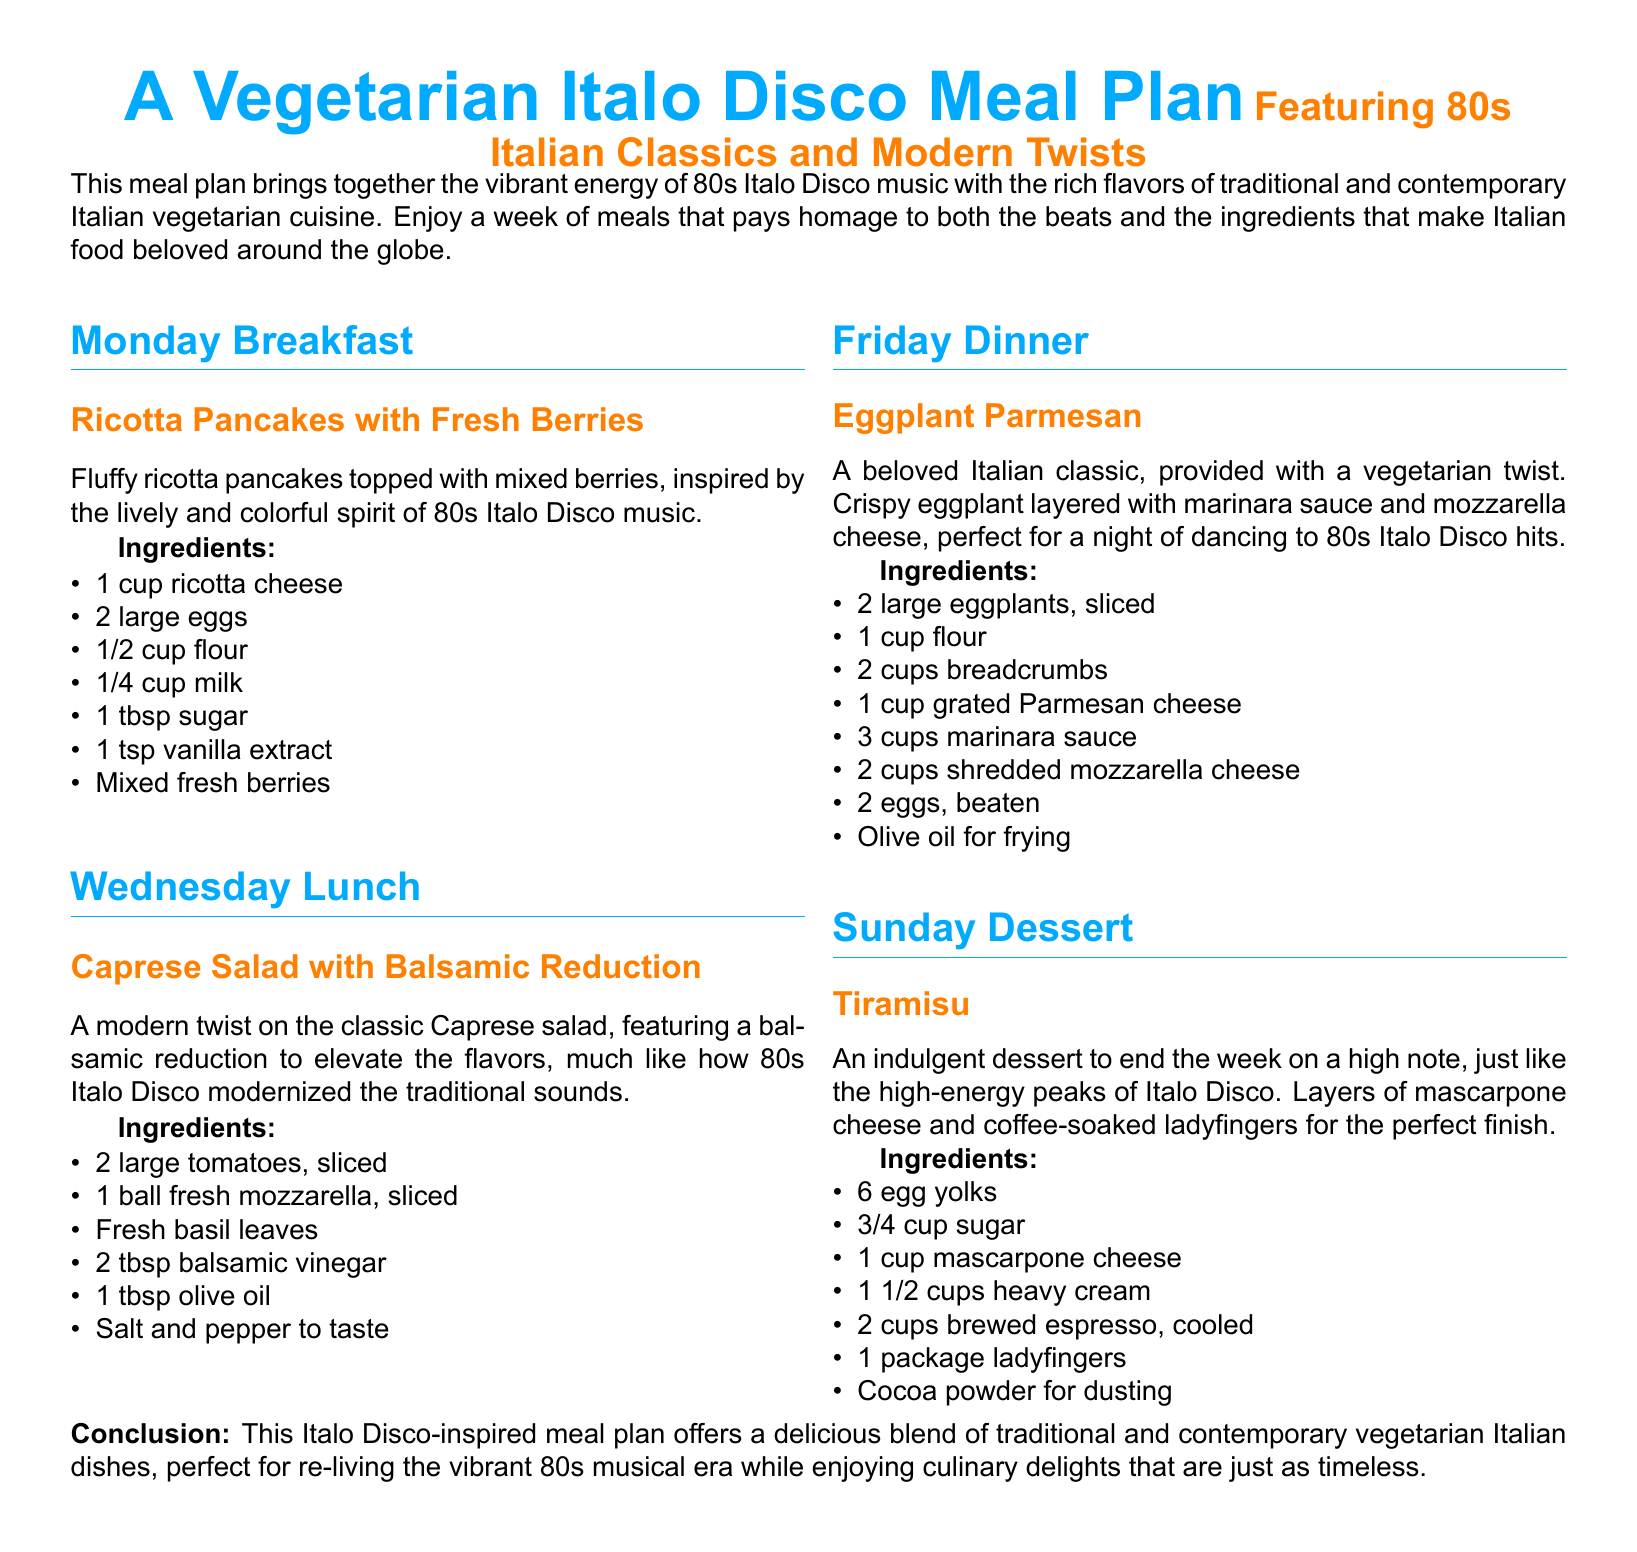What is the title of the meal plan? The title prominently displayed at the top is "A Vegetarian Italo Disco Meal Plan."
Answer: A Vegetarian Italo Disco Meal Plan What dish is served for Monday breakfast? The document specifies that Monday breakfast features "Ricotta Pancakes with Fresh Berries."
Answer: Ricotta Pancakes with Fresh Berries What is a key ingredient in the Caprese Salad? The Caprese Salad includes fresh mozzarella as one of its main ingredients.
Answer: Fresh mozzarella How many eggs are required for the Eggplant Parmesan? The recipe for Eggplant Parmesan calls for 2 eggs, as noted in the ingredient list.
Answer: 2 eggs Which dessert is featured on Sunday? The dessert listed for Sunday in the meal plan is "Tiramisu."
Answer: Tiramisu What color is used for section titles? The color used for section titles throughout the document is disco blue.
Answer: Disco blue What does the meal plan aim to combine? The meal plan aims to combine the flavors of Italian vegetarian cuisine with the spirit of 80s Italo Disco music.
Answer: Italian vegetarian cuisine and 80s Italo Disco music What type of meal plan is this document categorized as? The document is categorized as a meal plan, specifically a vegetarian meal plan featuring Italian dishes.
Answer: Meal plan How many dishes are mentioned in the meal plan? The meal plan specifies four distinct dishes across different meals.
Answer: Four dishes 